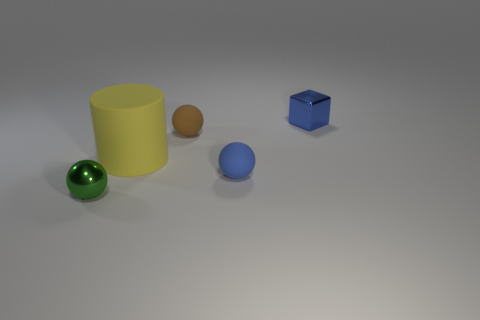Subtract all rubber spheres. How many spheres are left? 1 Add 1 cylinders. How many objects exist? 6 Subtract 0 green blocks. How many objects are left? 5 Subtract all balls. How many objects are left? 2 Subtract all red cylinders. Subtract all yellow balls. How many cylinders are left? 1 Subtract all green spheres. How many brown cylinders are left? 0 Subtract all cyan cubes. Subtract all tiny brown rubber balls. How many objects are left? 4 Add 2 big things. How many big things are left? 3 Add 5 blue objects. How many blue objects exist? 7 